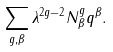Convert formula to latex. <formula><loc_0><loc_0><loc_500><loc_500>\sum _ { g , \beta } \lambda ^ { 2 g - 2 } N ^ { g } _ { \beta } q ^ { \beta } .</formula> 